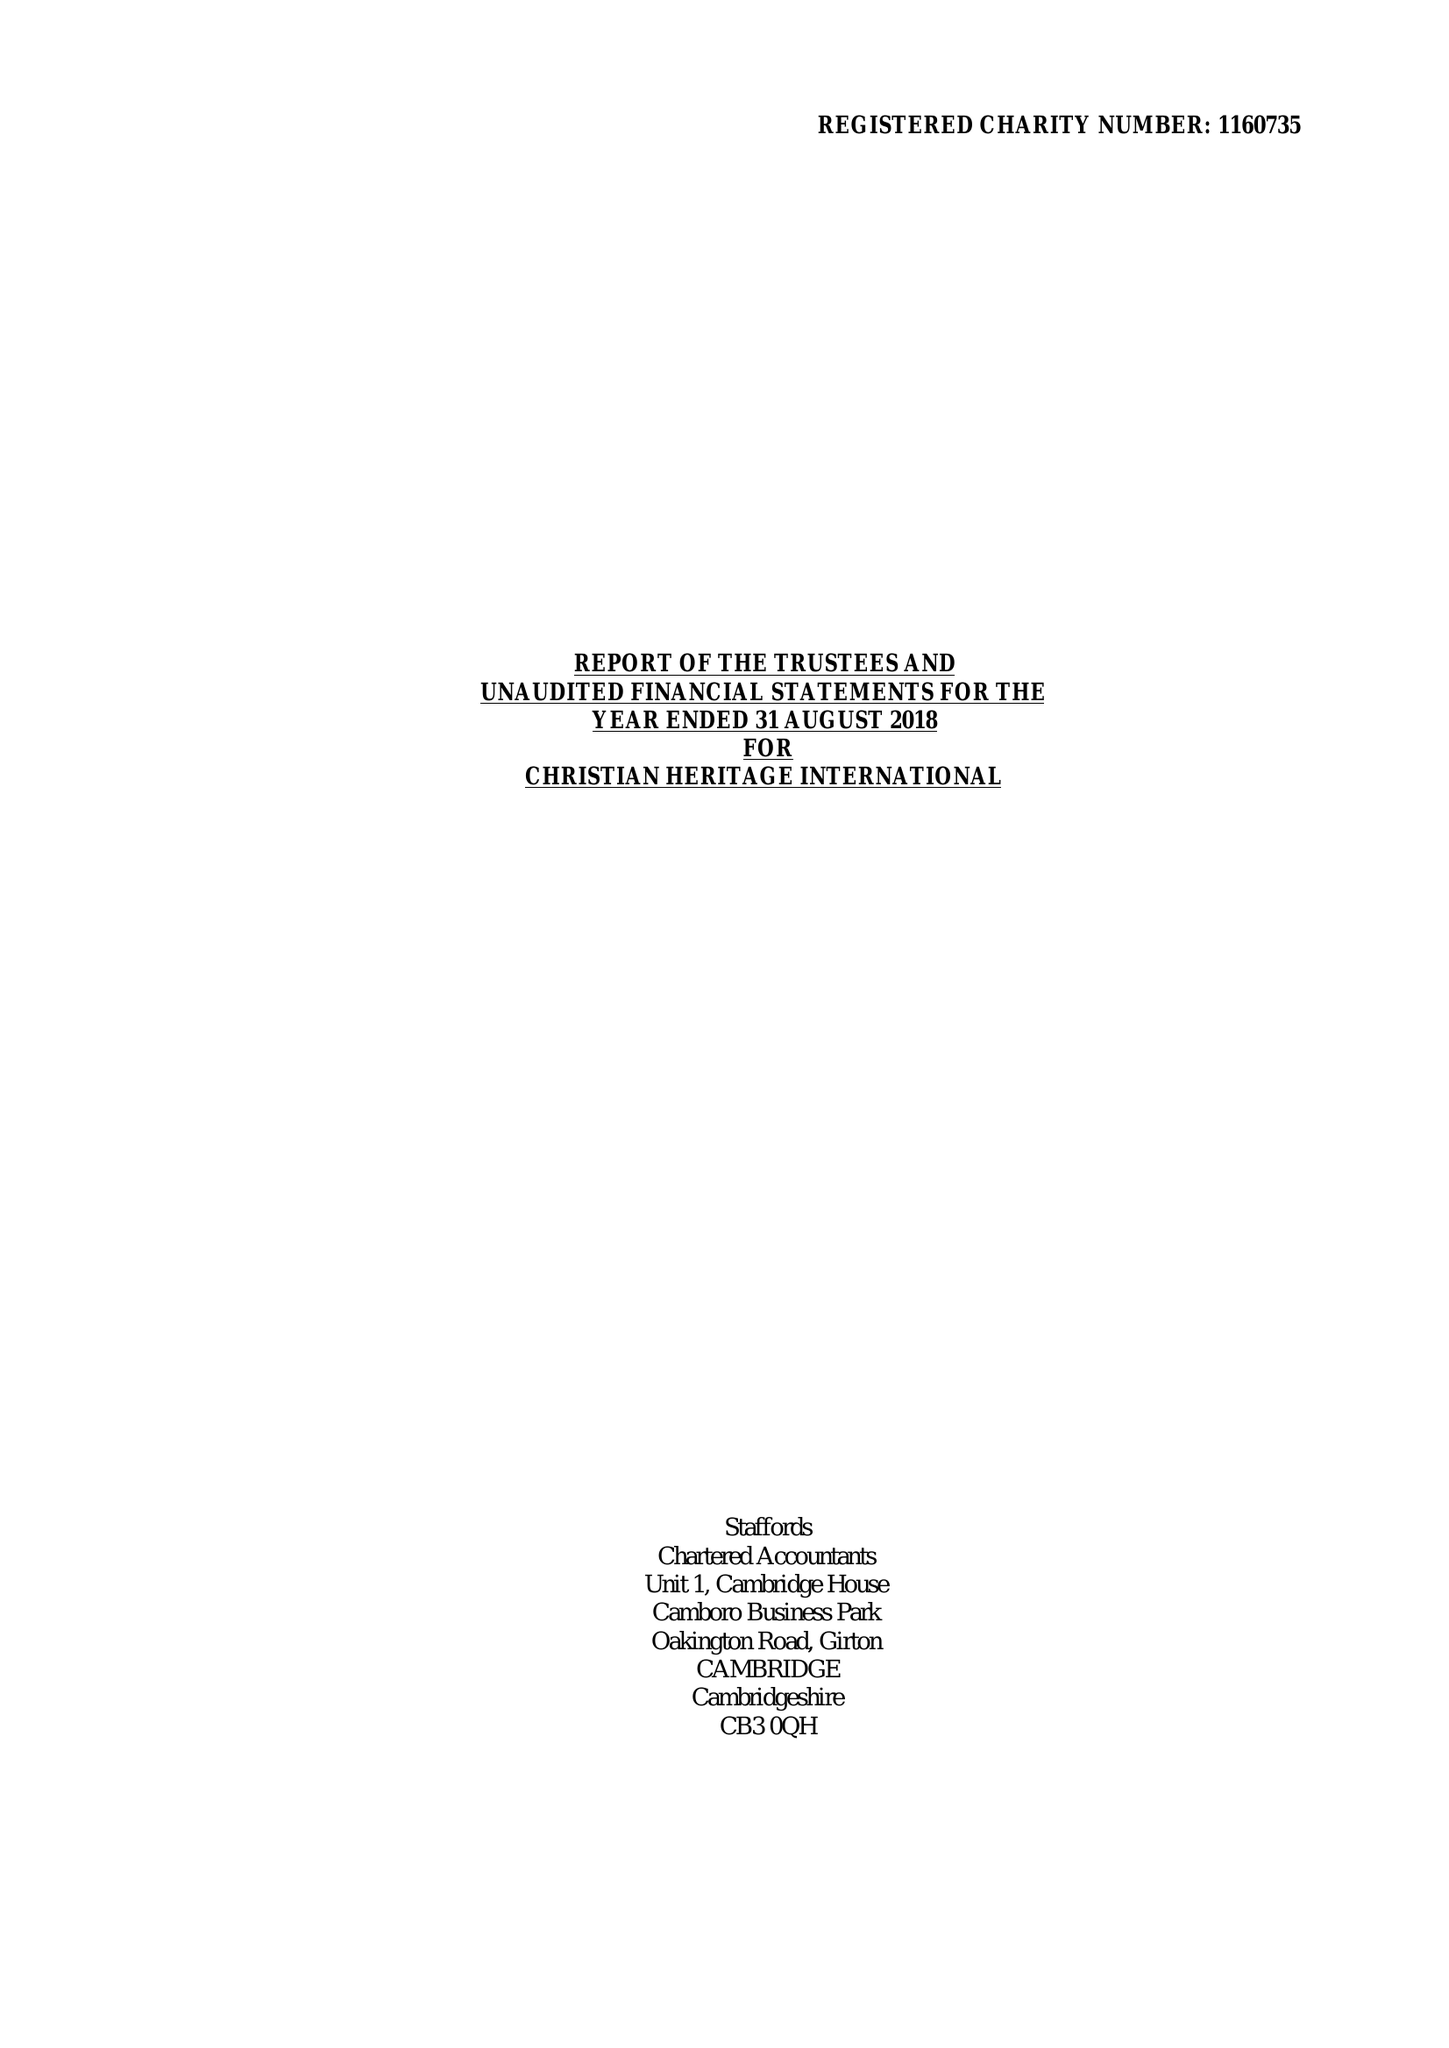What is the value for the address__postcode?
Answer the question using a single word or phrase. HA6 2UR 